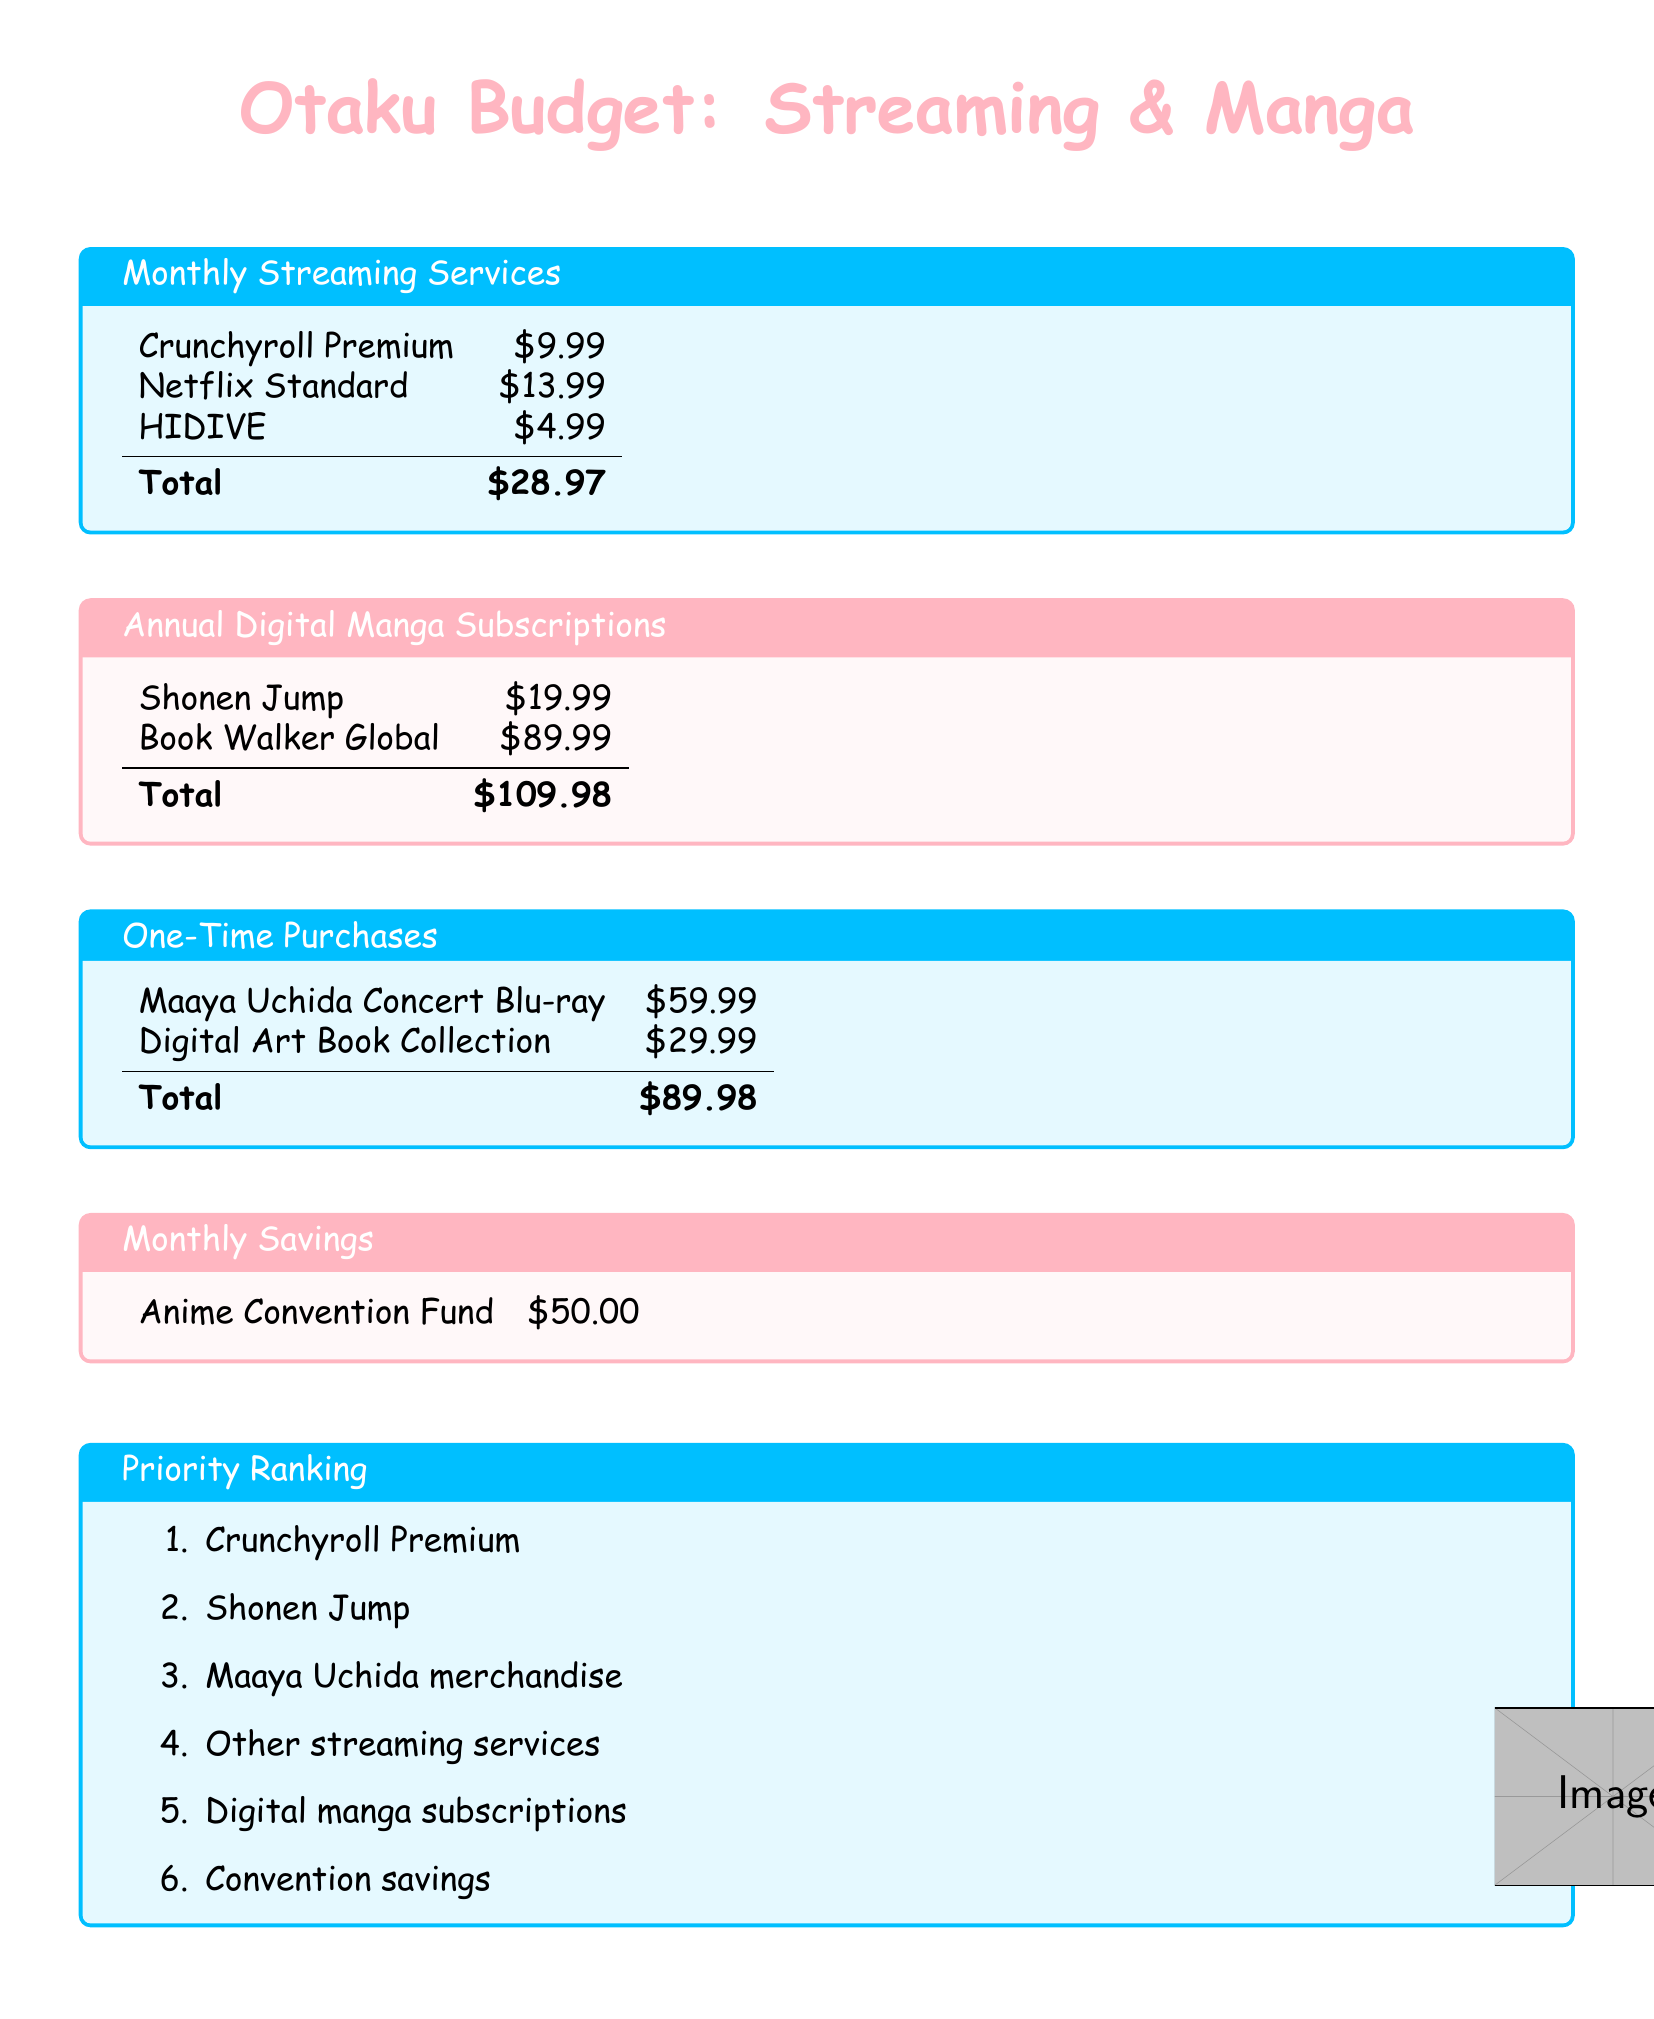what is the total cost of monthly streaming services? The total cost of monthly streaming services is found by adding the individual service costs: $9.99 + $13.99 + $4.99 = $28.97.
Answer: $28.97 what is the price of the Shonen Jump subscription? The price of the Shonen Jump subscription is presented in the annual digital manga subscriptions section.
Answer: $19.99 how much budget is allocated for one-time purchases? The budget for one-time purchases comes from adding the costs of Maaya Uchida Concert Blu-ray and Digital Art Book Collection: $59.99 + $29.99 = $89.98.
Answer: $89.98 which subscription has the highest cost? The subscription with the highest cost is found by comparing the listed prices. Book Walker Global at $89.99 is the highest.
Answer: Book Walker Global what is prioritized higher, other streaming services or digital manga subscriptions? To determine priority, refer to the Priority Ranking list and find the order of items. Other streaming services are ranked below digital manga subscriptions.
Answer: digital manga subscriptions how much is allocated for the Anime Convention Fund? The amount dedicated to the Anime Convention Fund can be found directly in the monthly savings section.
Answer: $50.00 which streaming service is listed first? The first streaming service listed appears in the monthly streaming services section.
Answer: Crunchyroll Premium how much does HIDIVE cost monthly? The monthly cost of HIDIVE is stated in the budget.
Answer: $4.99 what is the total amount for annual digital manga subscriptions? The total is calculated by adding Shonen Jump and Book Walker Global: $19.99 + $89.99 = $109.98.
Answer: $109.98 